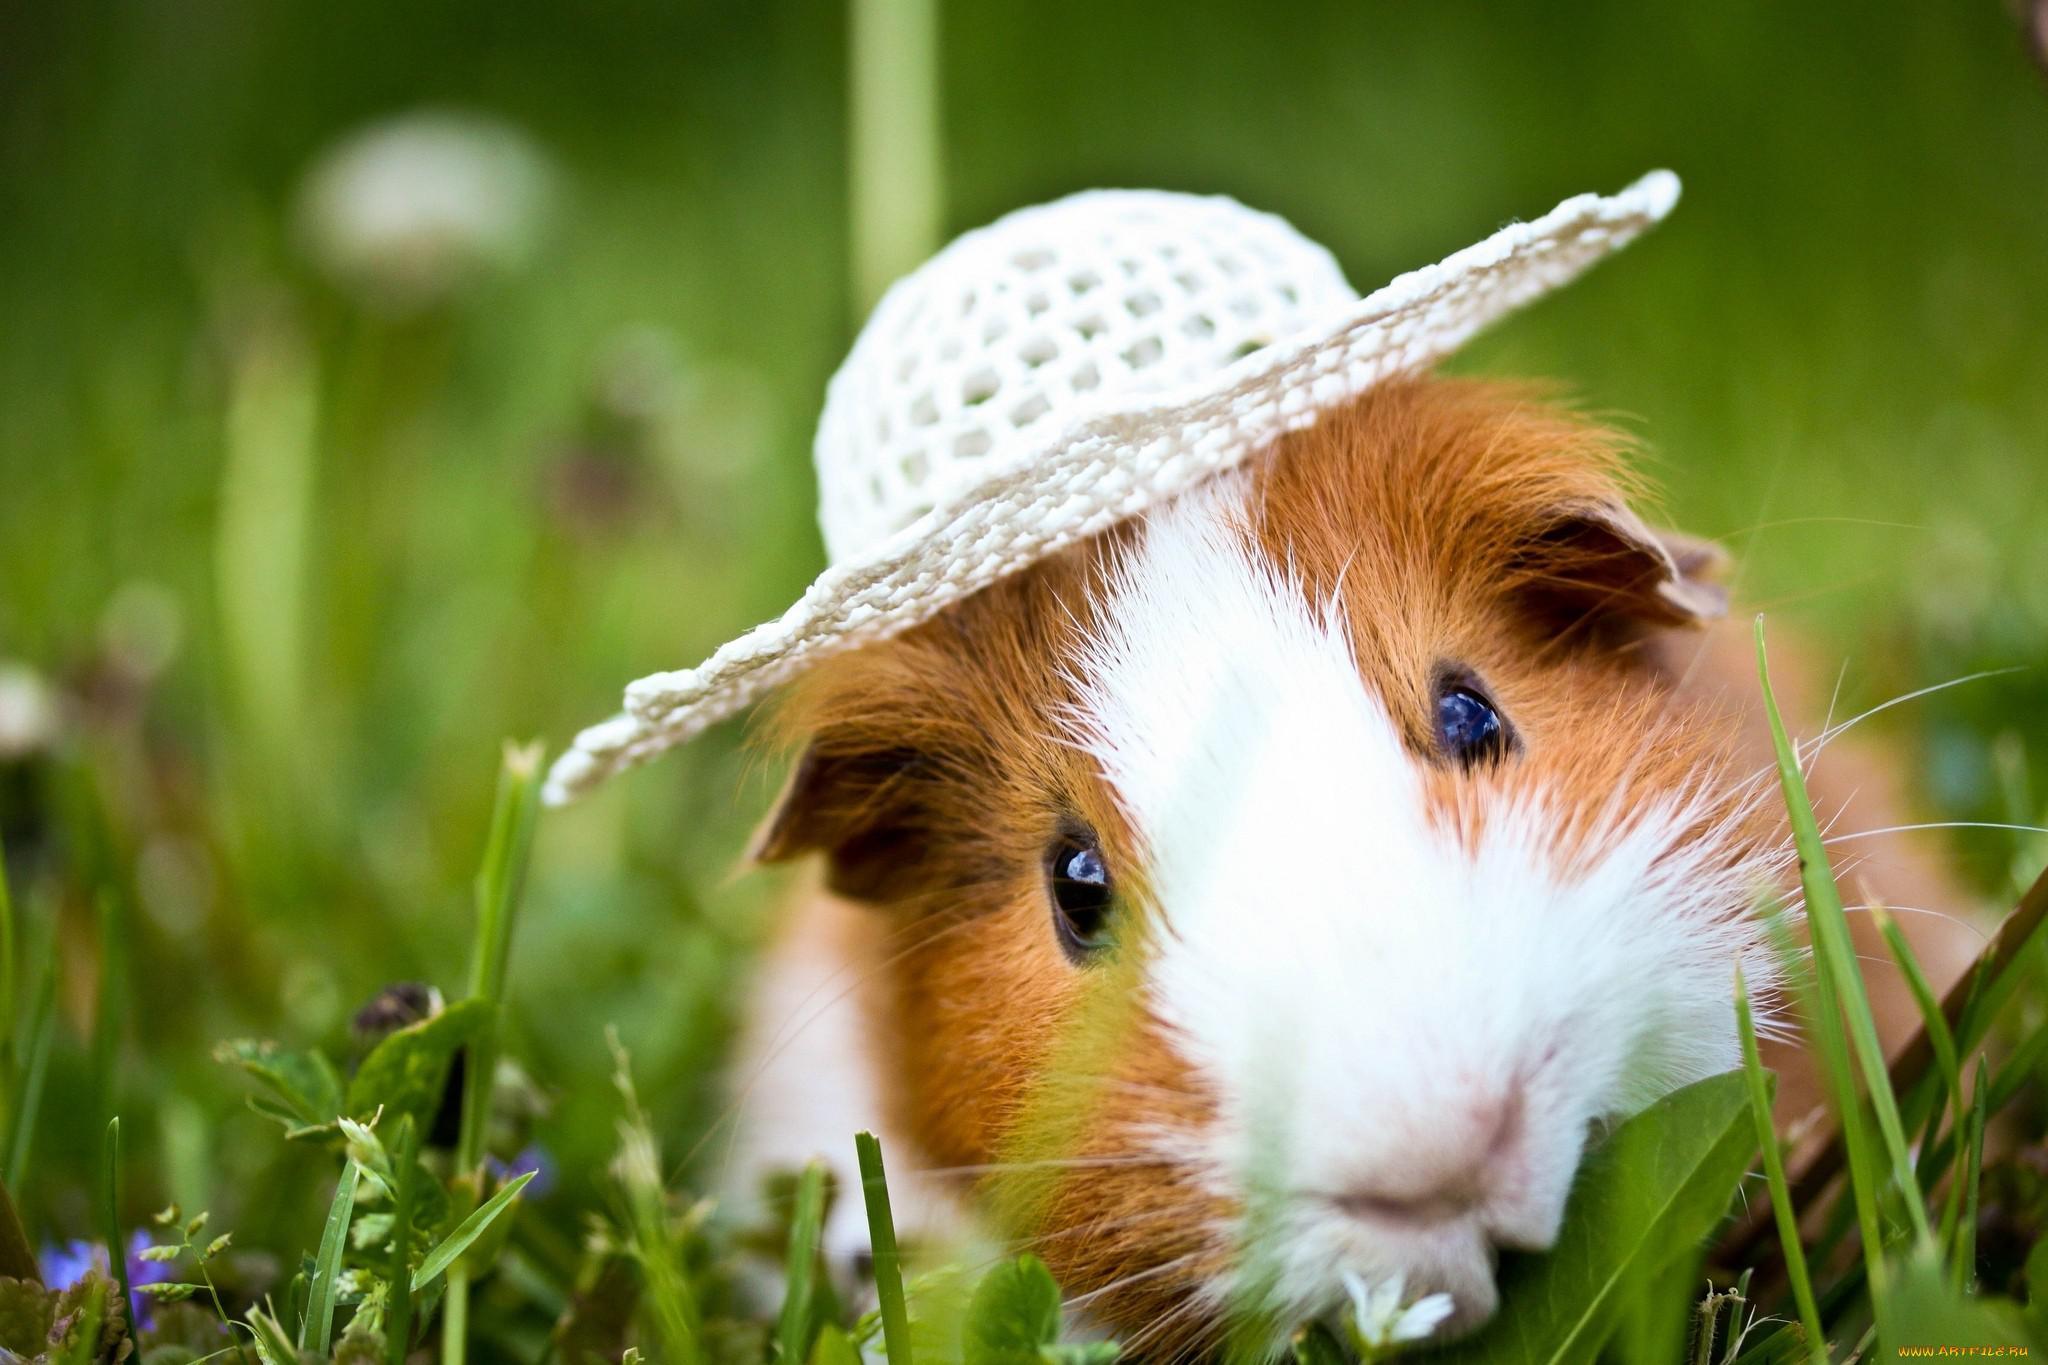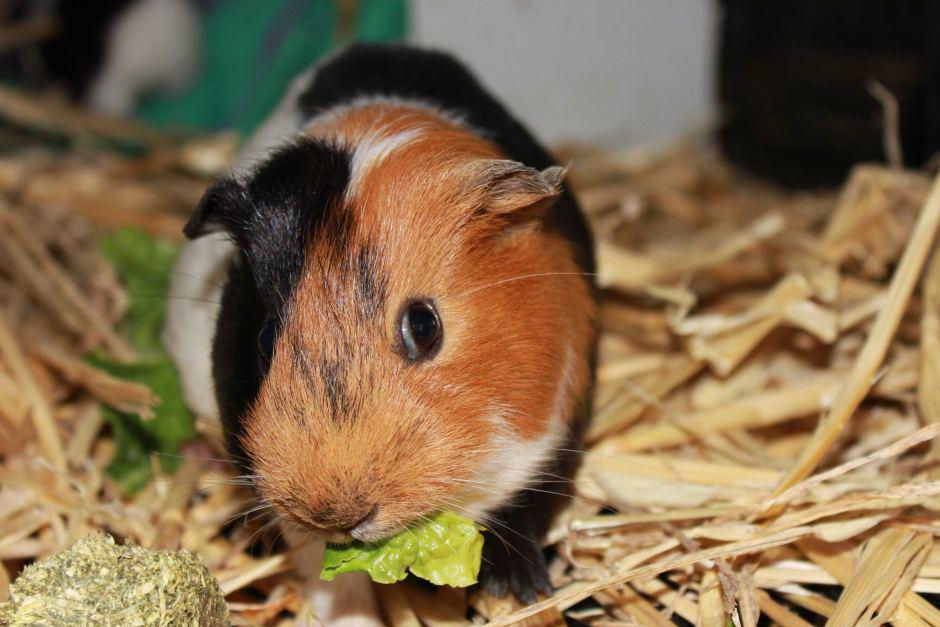The first image is the image on the left, the second image is the image on the right. Given the left and right images, does the statement "Each image contains a single guinea pig and only one guinea pig is standing on green grass." hold true? Answer yes or no. Yes. The first image is the image on the left, the second image is the image on the right. Given the left and right images, does the statement "At least one hamster is eating something in at least one of the images." hold true? Answer yes or no. Yes. 